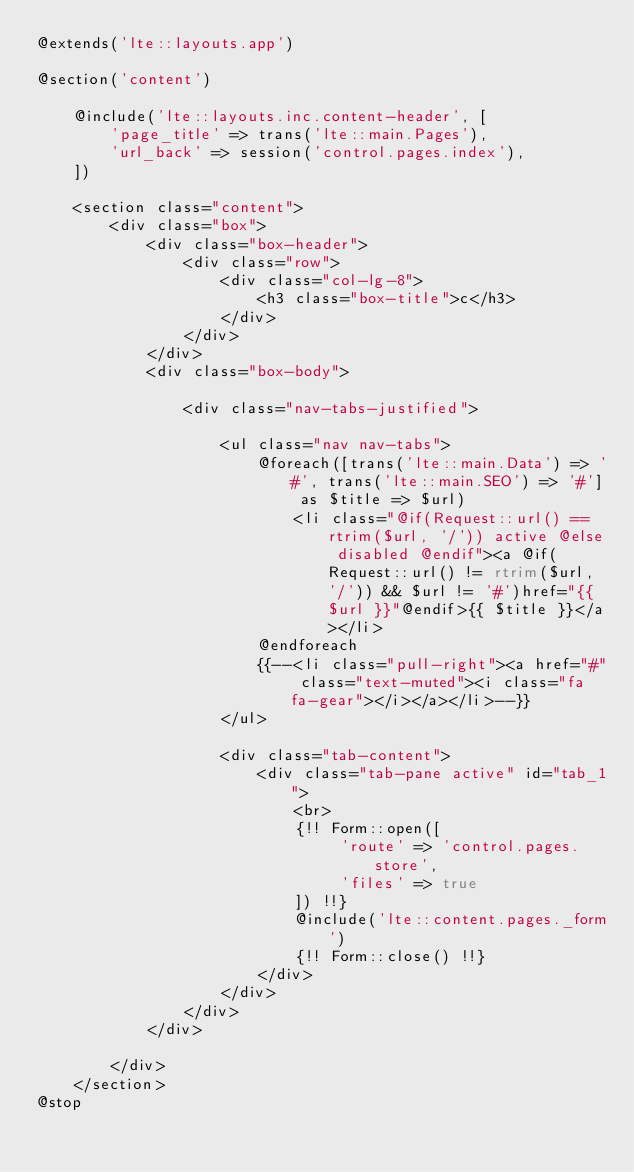Convert code to text. <code><loc_0><loc_0><loc_500><loc_500><_PHP_>@extends('lte::layouts.app')

@section('content')

    @include('lte::layouts.inc.content-header', [
        'page_title' => trans('lte::main.Pages'),
        'url_back' => session('control.pages.index'),
    ])

    <section class="content">
        <div class="box">
            <div class="box-header">
                <div class="row">
                    <div class="col-lg-8">
                        <h3 class="box-title">c</h3>
                    </div>
                </div>
            </div>
            <div class="box-body">

                <div class="nav-tabs-justified">

                    <ul class="nav nav-tabs">
                        @foreach([trans('lte::main.Data') => '#', trans('lte::main.SEO') => '#'] as $title => $url)
                            <li class="@if(Request::url() == rtrim($url, '/')) active @else disabled @endif"><a @if(Request::url() != rtrim($url, '/')) && $url != '#')href="{{ $url }}"@endif>{{ $title }}</a></li>
                        @endforeach
                        {{--<li class="pull-right"><a href="#" class="text-muted"><i class="fa fa-gear"></i></a></li>--}}
                    </ul>

                    <div class="tab-content">
                        <div class="tab-pane active" id="tab_1">
                            <br>
                            {!! Form::open([
                                 'route' => 'control.pages.store',
                                 'files' => true
                            ]) !!}
                            @include('lte::content.pages._form')
                            {!! Form::close() !!}
                        </div>
                    </div>
                </div>
            </div>

        </div>
    </section>
@stop
</code> 